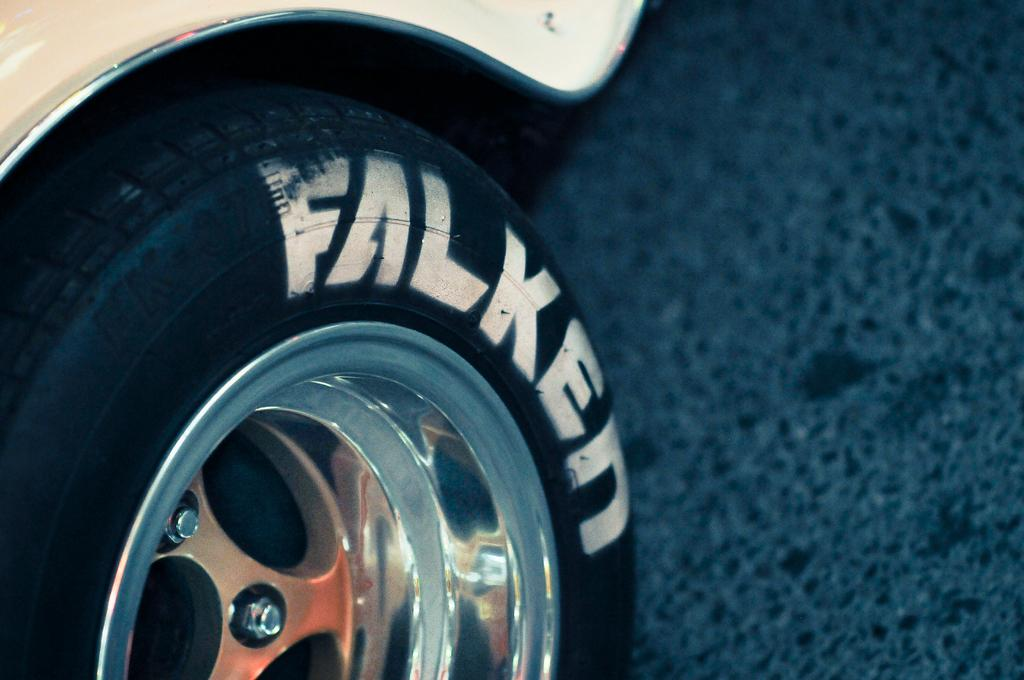What part of a vehicle can be seen in the image? There is a wheel of a vehicle in the image. Where is the vehicle located? The vehicle is on the road. What type of wood is the writer using to create their masterpiece in the image? There is no writer or wood present in the image; it only features a wheel of a vehicle on the road. 